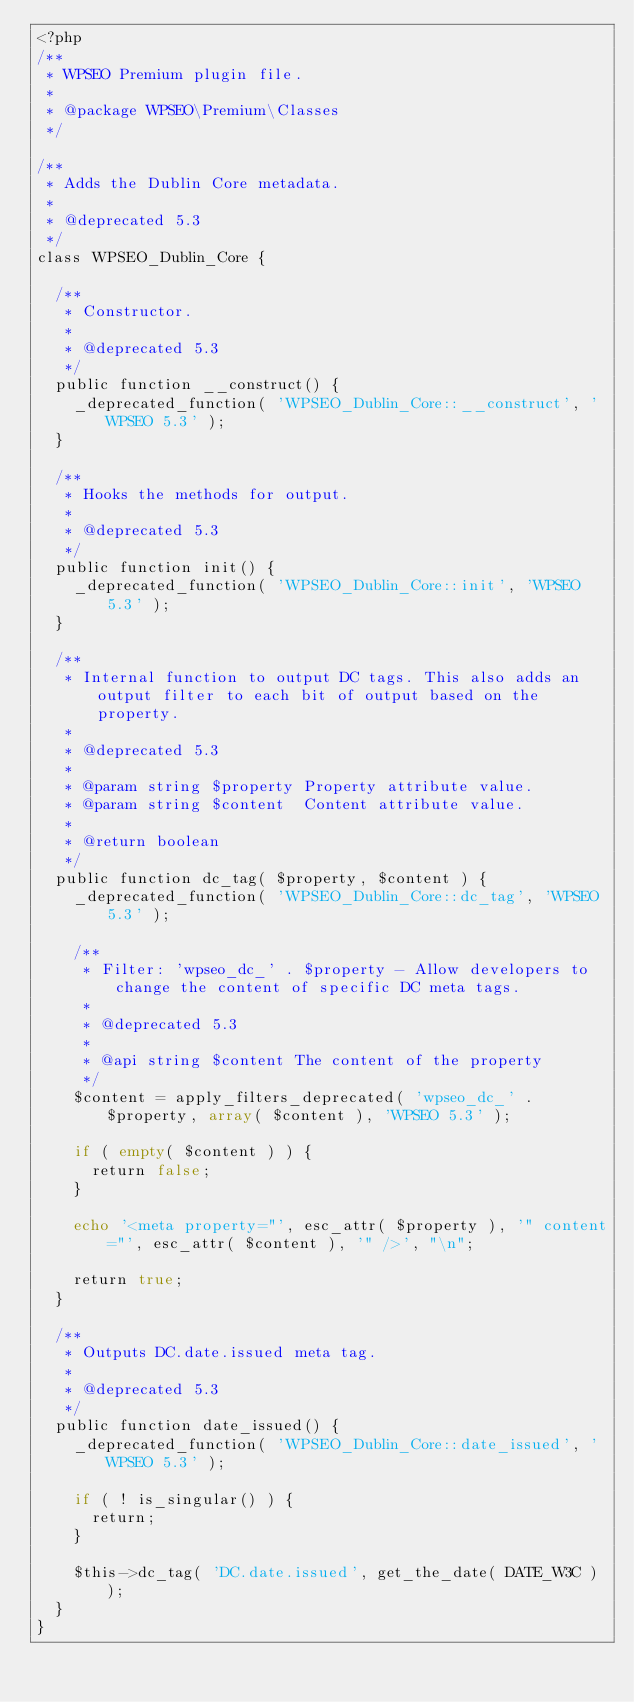Convert code to text. <code><loc_0><loc_0><loc_500><loc_500><_PHP_><?php
/**
 * WPSEO Premium plugin file.
 *
 * @package WPSEO\Premium\Classes
 */

/**
 * Adds the Dublin Core metadata.
 *
 * @deprecated 5.3
 */
class WPSEO_Dublin_Core {

	/**
	 * Constructor.
	 *
	 * @deprecated 5.3
	 */
	public function __construct() {
		_deprecated_function( 'WPSEO_Dublin_Core::__construct', 'WPSEO 5.3' );
	}

	/**
	 * Hooks the methods for output.
	 *
	 * @deprecated 5.3
	 */
	public function init() {
		_deprecated_function( 'WPSEO_Dublin_Core::init', 'WPSEO 5.3' );
	}

	/**
	 * Internal function to output DC tags. This also adds an output filter to each bit of output based on the property.
	 *
	 * @deprecated 5.3
	 *
	 * @param string $property Property attribute value.
	 * @param string $content  Content attribute value.
	 *
	 * @return boolean
	 */
	public function dc_tag( $property, $content ) {
		_deprecated_function( 'WPSEO_Dublin_Core::dc_tag', 'WPSEO 5.3' );

		/**
		 * Filter: 'wpseo_dc_' . $property - Allow developers to change the content of specific DC meta tags.
		 *
		 * @deprecated 5.3
		 *
		 * @api string $content The content of the property
		 */
		$content = apply_filters_deprecated( 'wpseo_dc_' . $property, array( $content ), 'WPSEO 5.3' );

		if ( empty( $content ) ) {
			return false;
		}

		echo '<meta property="', esc_attr( $property ), '" content="', esc_attr( $content ), '" />', "\n";

		return true;
	}

	/**
	 * Outputs DC.date.issued meta tag.
	 *
	 * @deprecated 5.3
	 */
	public function date_issued() {
		_deprecated_function( 'WPSEO_Dublin_Core::date_issued', 'WPSEO 5.3' );

		if ( ! is_singular() ) {
			return;
		}

		$this->dc_tag( 'DC.date.issued', get_the_date( DATE_W3C ) );
	}
}
</code> 